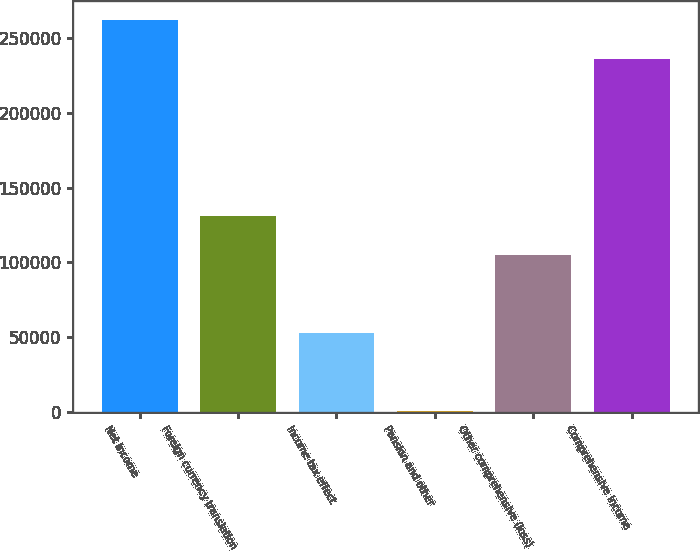<chart> <loc_0><loc_0><loc_500><loc_500><bar_chart><fcel>Net income<fcel>Foreign currency translation<fcel>Income tax effect<fcel>Pension and other<fcel>Other comprehensive (loss)<fcel>Comprehensive income<nl><fcel>261891<fcel>130725<fcel>52647<fcel>595<fcel>104699<fcel>235865<nl></chart> 